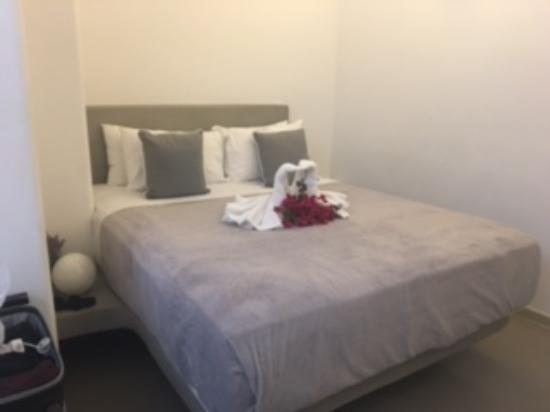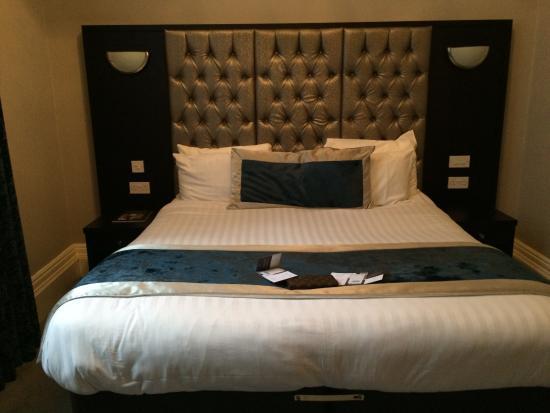The first image is the image on the left, the second image is the image on the right. For the images shown, is this caption "In 1 of the images, 1 bed is in front of a dimpled headboard." true? Answer yes or no. Yes. The first image is the image on the left, the second image is the image on the right. Analyze the images presented: Is the assertion "There are no less than three beds" valid? Answer yes or no. No. 